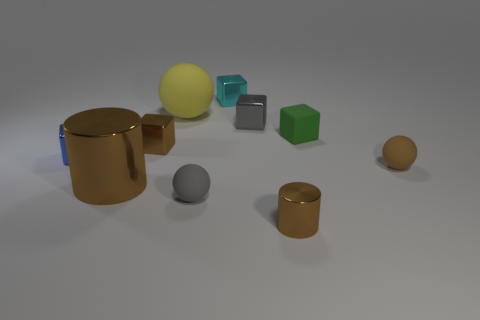Subtract all cyan blocks. How many blocks are left? 4 Subtract 2 blocks. How many blocks are left? 3 Subtract all matte blocks. How many blocks are left? 4 Subtract all purple blocks. Subtract all gray cylinders. How many blocks are left? 5 Subtract all cylinders. How many objects are left? 8 Add 1 blocks. How many blocks exist? 6 Subtract 1 gray blocks. How many objects are left? 9 Subtract all small matte blocks. Subtract all shiny cylinders. How many objects are left? 7 Add 9 yellow matte objects. How many yellow matte objects are left? 10 